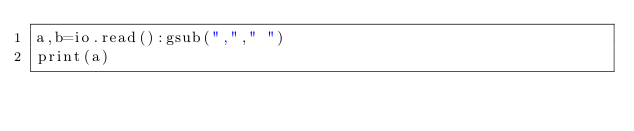<code> <loc_0><loc_0><loc_500><loc_500><_Lua_>a,b=io.read():gsub(","," ")
print(a)</code> 